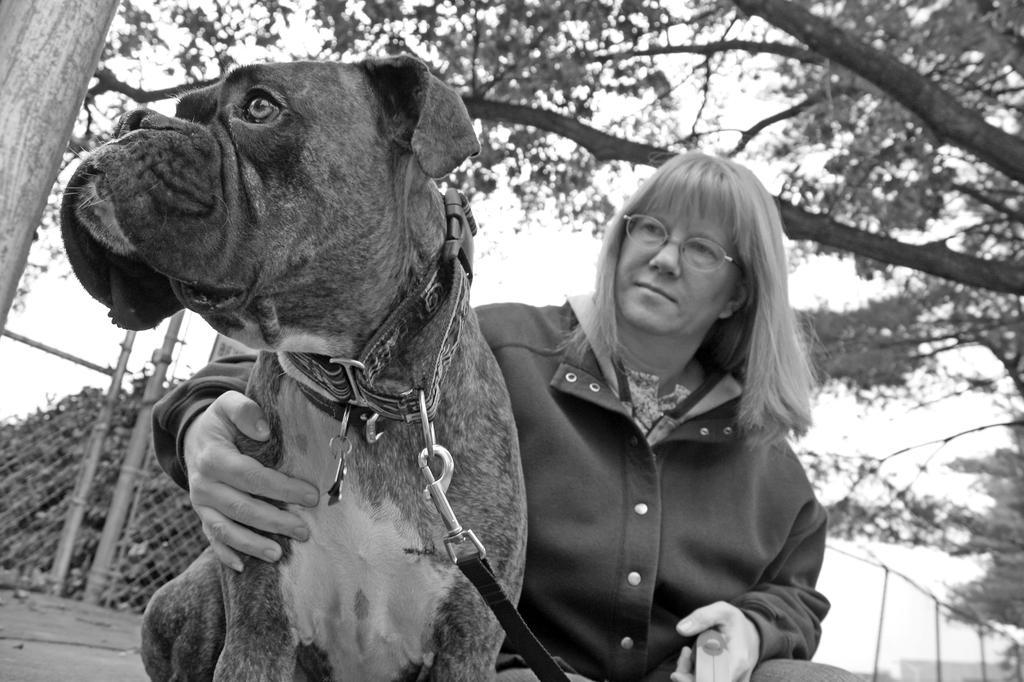Can you describe this image briefly? She is sitting. She is holding a dog. We can see in the background there is a tree. 